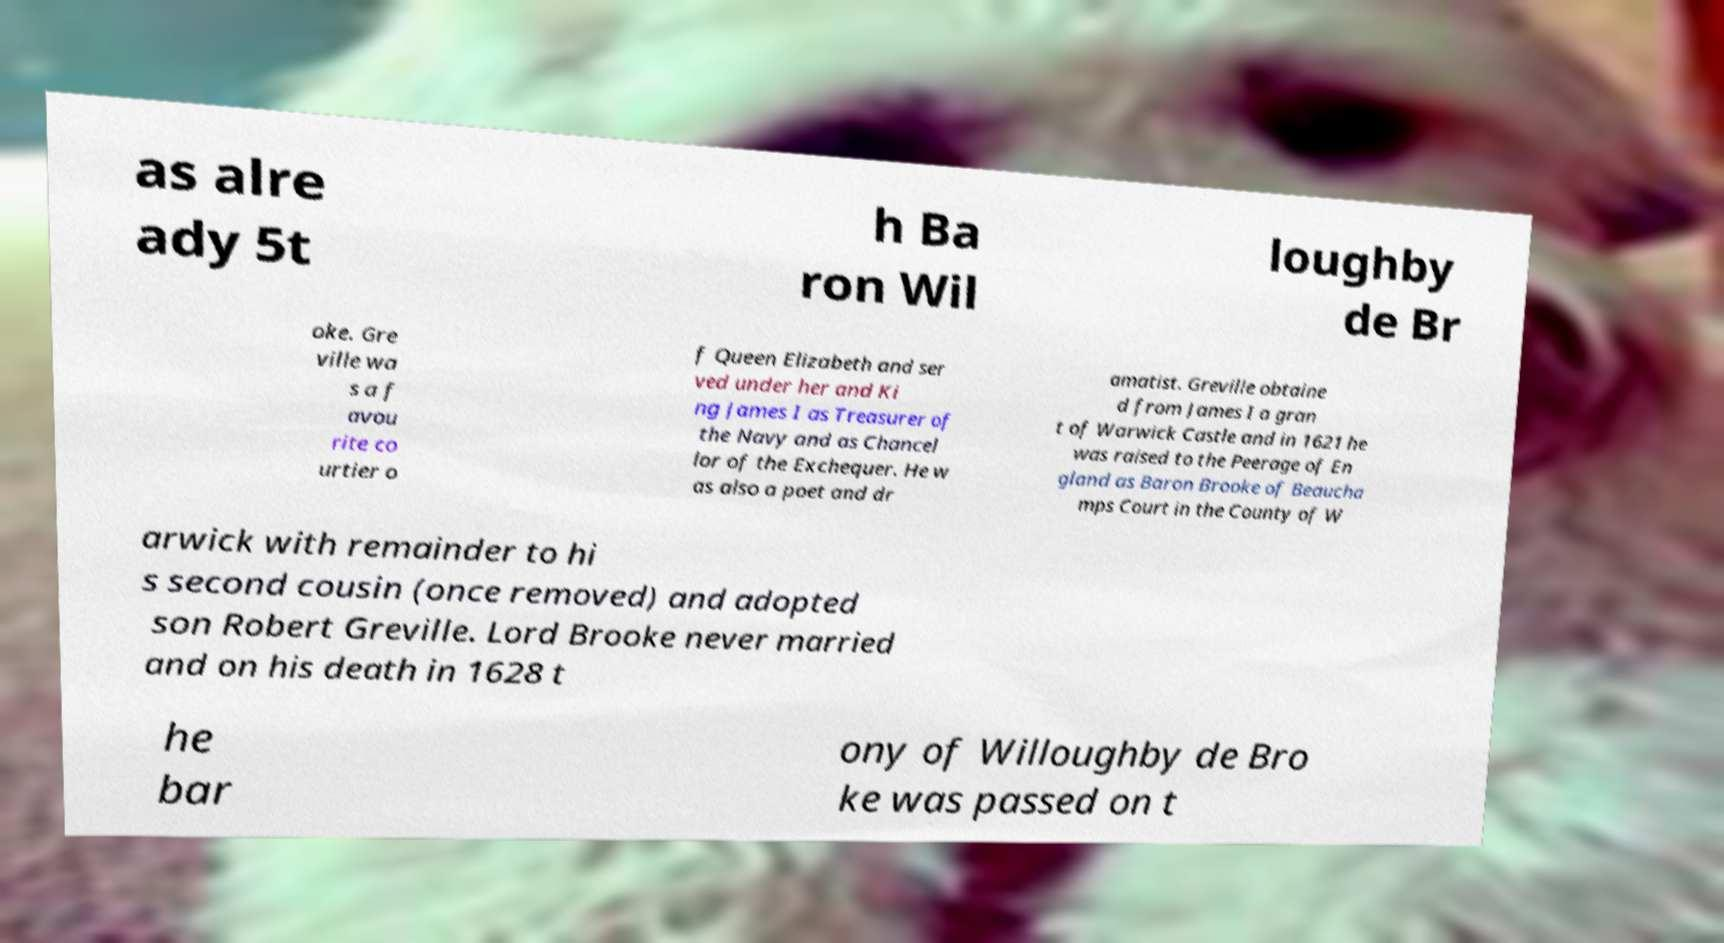Could you extract and type out the text from this image? as alre ady 5t h Ba ron Wil loughby de Br oke. Gre ville wa s a f avou rite co urtier o f Queen Elizabeth and ser ved under her and Ki ng James I as Treasurer of the Navy and as Chancel lor of the Exchequer. He w as also a poet and dr amatist. Greville obtaine d from James I a gran t of Warwick Castle and in 1621 he was raised to the Peerage of En gland as Baron Brooke of Beaucha mps Court in the County of W arwick with remainder to hi s second cousin (once removed) and adopted son Robert Greville. Lord Brooke never married and on his death in 1628 t he bar ony of Willoughby de Bro ke was passed on t 